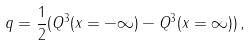Convert formula to latex. <formula><loc_0><loc_0><loc_500><loc_500>q = { \frac { 1 } { 2 } } ( Q ^ { 3 } ( x = - \infty ) - Q ^ { 3 } ( x = \infty ) ) \, ,</formula> 